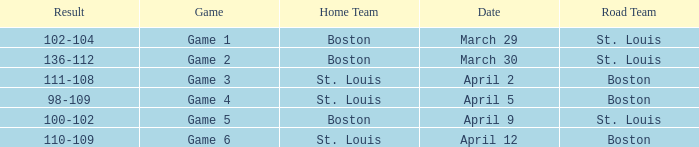What Game had a Result of 136-112? Game 2. 